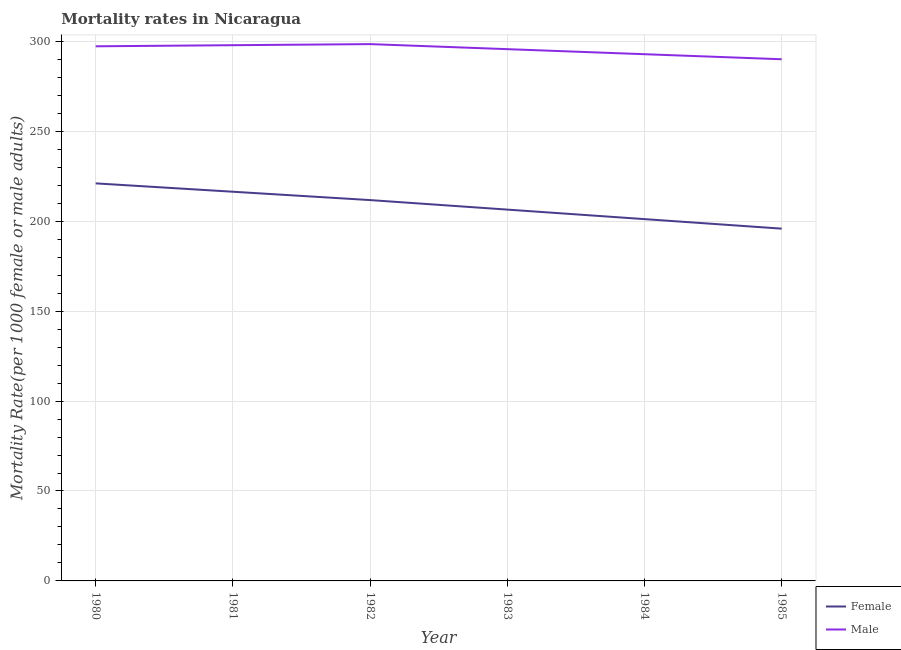Does the line corresponding to female mortality rate intersect with the line corresponding to male mortality rate?
Make the answer very short. No. What is the female mortality rate in 1981?
Your answer should be very brief. 216.38. Across all years, what is the maximum female mortality rate?
Your response must be concise. 221.02. Across all years, what is the minimum male mortality rate?
Offer a terse response. 290.03. In which year was the male mortality rate minimum?
Provide a short and direct response. 1985. What is the total male mortality rate in the graph?
Your answer should be compact. 1772.04. What is the difference between the female mortality rate in 1980 and that in 1984?
Provide a succinct answer. 19.87. What is the difference between the male mortality rate in 1983 and the female mortality rate in 1981?
Your answer should be very brief. 79.27. What is the average male mortality rate per year?
Make the answer very short. 295.34. In the year 1981, what is the difference between the female mortality rate and male mortality rate?
Your answer should be compact. -81.47. What is the ratio of the male mortality rate in 1980 to that in 1985?
Give a very brief answer. 1.02. What is the difference between the highest and the second highest male mortality rate?
Offer a very short reply. 0.61. What is the difference between the highest and the lowest male mortality rate?
Provide a short and direct response. 8.42. In how many years, is the male mortality rate greater than the average male mortality rate taken over all years?
Your response must be concise. 4. Is the sum of the male mortality rate in 1980 and 1985 greater than the maximum female mortality rate across all years?
Your response must be concise. Yes. How many lines are there?
Provide a succinct answer. 2. How many years are there in the graph?
Your response must be concise. 6. Are the values on the major ticks of Y-axis written in scientific E-notation?
Your answer should be compact. No. Where does the legend appear in the graph?
Offer a terse response. Bottom right. How many legend labels are there?
Ensure brevity in your answer.  2. How are the legend labels stacked?
Offer a very short reply. Vertical. What is the title of the graph?
Keep it short and to the point. Mortality rates in Nicaragua. Does "Register a property" appear as one of the legend labels in the graph?
Offer a very short reply. No. What is the label or title of the Y-axis?
Ensure brevity in your answer.  Mortality Rate(per 1000 female or male adults). What is the Mortality Rate(per 1000 female or male adults) in Female in 1980?
Provide a succinct answer. 221.02. What is the Mortality Rate(per 1000 female or male adults) of Male in 1980?
Give a very brief answer. 297.23. What is the Mortality Rate(per 1000 female or male adults) of Female in 1981?
Provide a short and direct response. 216.38. What is the Mortality Rate(per 1000 female or male adults) in Male in 1981?
Your response must be concise. 297.84. What is the Mortality Rate(per 1000 female or male adults) in Female in 1982?
Offer a very short reply. 211.73. What is the Mortality Rate(per 1000 female or male adults) of Male in 1982?
Make the answer very short. 298.45. What is the Mortality Rate(per 1000 female or male adults) in Female in 1983?
Offer a very short reply. 206.44. What is the Mortality Rate(per 1000 female or male adults) of Male in 1983?
Provide a short and direct response. 295.64. What is the Mortality Rate(per 1000 female or male adults) of Female in 1984?
Make the answer very short. 201.15. What is the Mortality Rate(per 1000 female or male adults) in Male in 1984?
Give a very brief answer. 292.84. What is the Mortality Rate(per 1000 female or male adults) in Female in 1985?
Give a very brief answer. 195.86. What is the Mortality Rate(per 1000 female or male adults) in Male in 1985?
Give a very brief answer. 290.03. Across all years, what is the maximum Mortality Rate(per 1000 female or male adults) of Female?
Provide a succinct answer. 221.02. Across all years, what is the maximum Mortality Rate(per 1000 female or male adults) of Male?
Provide a short and direct response. 298.45. Across all years, what is the minimum Mortality Rate(per 1000 female or male adults) of Female?
Your response must be concise. 195.86. Across all years, what is the minimum Mortality Rate(per 1000 female or male adults) in Male?
Make the answer very short. 290.03. What is the total Mortality Rate(per 1000 female or male adults) of Female in the graph?
Your response must be concise. 1252.57. What is the total Mortality Rate(per 1000 female or male adults) in Male in the graph?
Provide a succinct answer. 1772.04. What is the difference between the Mortality Rate(per 1000 female or male adults) of Female in 1980 and that in 1981?
Make the answer very short. 4.64. What is the difference between the Mortality Rate(per 1000 female or male adults) in Male in 1980 and that in 1981?
Make the answer very short. -0.61. What is the difference between the Mortality Rate(per 1000 female or male adults) of Female in 1980 and that in 1982?
Offer a very short reply. 9.29. What is the difference between the Mortality Rate(per 1000 female or male adults) of Male in 1980 and that in 1982?
Your response must be concise. -1.22. What is the difference between the Mortality Rate(per 1000 female or male adults) of Female in 1980 and that in 1983?
Ensure brevity in your answer.  14.58. What is the difference between the Mortality Rate(per 1000 female or male adults) of Male in 1980 and that in 1983?
Offer a terse response. 1.59. What is the difference between the Mortality Rate(per 1000 female or male adults) in Female in 1980 and that in 1984?
Ensure brevity in your answer.  19.87. What is the difference between the Mortality Rate(per 1000 female or male adults) of Male in 1980 and that in 1984?
Give a very brief answer. 4.39. What is the difference between the Mortality Rate(per 1000 female or male adults) in Female in 1980 and that in 1985?
Keep it short and to the point. 25.16. What is the difference between the Mortality Rate(per 1000 female or male adults) of Female in 1981 and that in 1982?
Ensure brevity in your answer.  4.64. What is the difference between the Mortality Rate(per 1000 female or male adults) in Male in 1981 and that in 1982?
Your answer should be very brief. -0.61. What is the difference between the Mortality Rate(per 1000 female or male adults) in Female in 1981 and that in 1983?
Provide a short and direct response. 9.94. What is the difference between the Mortality Rate(per 1000 female or male adults) in Male in 1981 and that in 1983?
Provide a short and direct response. 2.2. What is the difference between the Mortality Rate(per 1000 female or male adults) in Female in 1981 and that in 1984?
Ensure brevity in your answer.  15.23. What is the difference between the Mortality Rate(per 1000 female or male adults) in Male in 1981 and that in 1984?
Ensure brevity in your answer.  5. What is the difference between the Mortality Rate(per 1000 female or male adults) in Female in 1981 and that in 1985?
Your response must be concise. 20.52. What is the difference between the Mortality Rate(per 1000 female or male adults) of Male in 1981 and that in 1985?
Keep it short and to the point. 7.81. What is the difference between the Mortality Rate(per 1000 female or male adults) of Female in 1982 and that in 1983?
Keep it short and to the point. 5.29. What is the difference between the Mortality Rate(per 1000 female or male adults) in Male in 1982 and that in 1983?
Offer a terse response. 2.81. What is the difference between the Mortality Rate(per 1000 female or male adults) in Female in 1982 and that in 1984?
Offer a very short reply. 10.58. What is the difference between the Mortality Rate(per 1000 female or male adults) of Male in 1982 and that in 1984?
Keep it short and to the point. 5.61. What is the difference between the Mortality Rate(per 1000 female or male adults) of Female in 1982 and that in 1985?
Provide a succinct answer. 15.87. What is the difference between the Mortality Rate(per 1000 female or male adults) in Male in 1982 and that in 1985?
Ensure brevity in your answer.  8.42. What is the difference between the Mortality Rate(per 1000 female or male adults) of Female in 1983 and that in 1984?
Your answer should be very brief. 5.29. What is the difference between the Mortality Rate(per 1000 female or male adults) in Male in 1983 and that in 1984?
Your response must be concise. 2.81. What is the difference between the Mortality Rate(per 1000 female or male adults) in Female in 1983 and that in 1985?
Your response must be concise. 10.58. What is the difference between the Mortality Rate(per 1000 female or male adults) of Male in 1983 and that in 1985?
Your answer should be compact. 5.61. What is the difference between the Mortality Rate(per 1000 female or male adults) of Female in 1984 and that in 1985?
Offer a very short reply. 5.29. What is the difference between the Mortality Rate(per 1000 female or male adults) in Male in 1984 and that in 1985?
Give a very brief answer. 2.81. What is the difference between the Mortality Rate(per 1000 female or male adults) of Female in 1980 and the Mortality Rate(per 1000 female or male adults) of Male in 1981?
Provide a short and direct response. -76.82. What is the difference between the Mortality Rate(per 1000 female or male adults) of Female in 1980 and the Mortality Rate(per 1000 female or male adults) of Male in 1982?
Make the answer very short. -77.43. What is the difference between the Mortality Rate(per 1000 female or male adults) in Female in 1980 and the Mortality Rate(per 1000 female or male adults) in Male in 1983?
Offer a terse response. -74.62. What is the difference between the Mortality Rate(per 1000 female or male adults) in Female in 1980 and the Mortality Rate(per 1000 female or male adults) in Male in 1984?
Make the answer very short. -71.82. What is the difference between the Mortality Rate(per 1000 female or male adults) in Female in 1980 and the Mortality Rate(per 1000 female or male adults) in Male in 1985?
Offer a very short reply. -69.01. What is the difference between the Mortality Rate(per 1000 female or male adults) of Female in 1981 and the Mortality Rate(per 1000 female or male adults) of Male in 1982?
Make the answer very short. -82.08. What is the difference between the Mortality Rate(per 1000 female or male adults) of Female in 1981 and the Mortality Rate(per 1000 female or male adults) of Male in 1983?
Your answer should be compact. -79.27. What is the difference between the Mortality Rate(per 1000 female or male adults) in Female in 1981 and the Mortality Rate(per 1000 female or male adults) in Male in 1984?
Provide a short and direct response. -76.46. What is the difference between the Mortality Rate(per 1000 female or male adults) of Female in 1981 and the Mortality Rate(per 1000 female or male adults) of Male in 1985?
Your answer should be very brief. -73.66. What is the difference between the Mortality Rate(per 1000 female or male adults) of Female in 1982 and the Mortality Rate(per 1000 female or male adults) of Male in 1983?
Your answer should be compact. -83.92. What is the difference between the Mortality Rate(per 1000 female or male adults) of Female in 1982 and the Mortality Rate(per 1000 female or male adults) of Male in 1984?
Offer a very short reply. -81.11. What is the difference between the Mortality Rate(per 1000 female or male adults) in Female in 1982 and the Mortality Rate(per 1000 female or male adults) in Male in 1985?
Your answer should be very brief. -78.3. What is the difference between the Mortality Rate(per 1000 female or male adults) of Female in 1983 and the Mortality Rate(per 1000 female or male adults) of Male in 1984?
Ensure brevity in your answer.  -86.4. What is the difference between the Mortality Rate(per 1000 female or male adults) of Female in 1983 and the Mortality Rate(per 1000 female or male adults) of Male in 1985?
Your answer should be compact. -83.59. What is the difference between the Mortality Rate(per 1000 female or male adults) of Female in 1984 and the Mortality Rate(per 1000 female or male adults) of Male in 1985?
Your answer should be compact. -88.88. What is the average Mortality Rate(per 1000 female or male adults) of Female per year?
Your response must be concise. 208.76. What is the average Mortality Rate(per 1000 female or male adults) in Male per year?
Give a very brief answer. 295.34. In the year 1980, what is the difference between the Mortality Rate(per 1000 female or male adults) of Female and Mortality Rate(per 1000 female or male adults) of Male?
Keep it short and to the point. -76.21. In the year 1981, what is the difference between the Mortality Rate(per 1000 female or male adults) of Female and Mortality Rate(per 1000 female or male adults) of Male?
Your response must be concise. -81.47. In the year 1982, what is the difference between the Mortality Rate(per 1000 female or male adults) in Female and Mortality Rate(per 1000 female or male adults) in Male?
Make the answer very short. -86.72. In the year 1983, what is the difference between the Mortality Rate(per 1000 female or male adults) of Female and Mortality Rate(per 1000 female or male adults) of Male?
Offer a terse response. -89.2. In the year 1984, what is the difference between the Mortality Rate(per 1000 female or male adults) in Female and Mortality Rate(per 1000 female or male adults) in Male?
Give a very brief answer. -91.69. In the year 1985, what is the difference between the Mortality Rate(per 1000 female or male adults) of Female and Mortality Rate(per 1000 female or male adults) of Male?
Provide a succinct answer. -94.17. What is the ratio of the Mortality Rate(per 1000 female or male adults) of Female in 1980 to that in 1981?
Offer a terse response. 1.02. What is the ratio of the Mortality Rate(per 1000 female or male adults) in Male in 1980 to that in 1981?
Your response must be concise. 1. What is the ratio of the Mortality Rate(per 1000 female or male adults) of Female in 1980 to that in 1982?
Keep it short and to the point. 1.04. What is the ratio of the Mortality Rate(per 1000 female or male adults) of Male in 1980 to that in 1982?
Offer a terse response. 1. What is the ratio of the Mortality Rate(per 1000 female or male adults) in Female in 1980 to that in 1983?
Offer a very short reply. 1.07. What is the ratio of the Mortality Rate(per 1000 female or male adults) in Male in 1980 to that in 1983?
Provide a succinct answer. 1.01. What is the ratio of the Mortality Rate(per 1000 female or male adults) of Female in 1980 to that in 1984?
Your answer should be compact. 1.1. What is the ratio of the Mortality Rate(per 1000 female or male adults) of Male in 1980 to that in 1984?
Offer a terse response. 1.01. What is the ratio of the Mortality Rate(per 1000 female or male adults) of Female in 1980 to that in 1985?
Your response must be concise. 1.13. What is the ratio of the Mortality Rate(per 1000 female or male adults) of Male in 1980 to that in 1985?
Give a very brief answer. 1.02. What is the ratio of the Mortality Rate(per 1000 female or male adults) in Female in 1981 to that in 1982?
Your answer should be compact. 1.02. What is the ratio of the Mortality Rate(per 1000 female or male adults) of Female in 1981 to that in 1983?
Make the answer very short. 1.05. What is the ratio of the Mortality Rate(per 1000 female or male adults) of Male in 1981 to that in 1983?
Ensure brevity in your answer.  1.01. What is the ratio of the Mortality Rate(per 1000 female or male adults) of Female in 1981 to that in 1984?
Provide a short and direct response. 1.08. What is the ratio of the Mortality Rate(per 1000 female or male adults) of Male in 1981 to that in 1984?
Give a very brief answer. 1.02. What is the ratio of the Mortality Rate(per 1000 female or male adults) of Female in 1981 to that in 1985?
Give a very brief answer. 1.1. What is the ratio of the Mortality Rate(per 1000 female or male adults) in Male in 1981 to that in 1985?
Ensure brevity in your answer.  1.03. What is the ratio of the Mortality Rate(per 1000 female or male adults) of Female in 1982 to that in 1983?
Offer a very short reply. 1.03. What is the ratio of the Mortality Rate(per 1000 female or male adults) of Male in 1982 to that in 1983?
Offer a very short reply. 1.01. What is the ratio of the Mortality Rate(per 1000 female or male adults) in Female in 1982 to that in 1984?
Your answer should be compact. 1.05. What is the ratio of the Mortality Rate(per 1000 female or male adults) of Male in 1982 to that in 1984?
Make the answer very short. 1.02. What is the ratio of the Mortality Rate(per 1000 female or male adults) in Female in 1982 to that in 1985?
Ensure brevity in your answer.  1.08. What is the ratio of the Mortality Rate(per 1000 female or male adults) of Male in 1982 to that in 1985?
Your answer should be very brief. 1.03. What is the ratio of the Mortality Rate(per 1000 female or male adults) in Female in 1983 to that in 1984?
Your answer should be very brief. 1.03. What is the ratio of the Mortality Rate(per 1000 female or male adults) in Male in 1983 to that in 1984?
Give a very brief answer. 1.01. What is the ratio of the Mortality Rate(per 1000 female or male adults) in Female in 1983 to that in 1985?
Keep it short and to the point. 1.05. What is the ratio of the Mortality Rate(per 1000 female or male adults) of Male in 1983 to that in 1985?
Your response must be concise. 1.02. What is the ratio of the Mortality Rate(per 1000 female or male adults) of Male in 1984 to that in 1985?
Provide a short and direct response. 1.01. What is the difference between the highest and the second highest Mortality Rate(per 1000 female or male adults) in Female?
Ensure brevity in your answer.  4.64. What is the difference between the highest and the second highest Mortality Rate(per 1000 female or male adults) in Male?
Give a very brief answer. 0.61. What is the difference between the highest and the lowest Mortality Rate(per 1000 female or male adults) in Female?
Provide a short and direct response. 25.16. What is the difference between the highest and the lowest Mortality Rate(per 1000 female or male adults) in Male?
Provide a succinct answer. 8.42. 